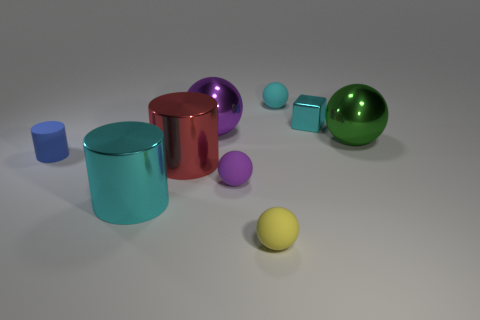Subtract all green balls. How many balls are left? 4 Subtract all green balls. How many balls are left? 4 Subtract all gray cylinders. How many brown blocks are left? 0 Subtract 0 red balls. How many objects are left? 9 Subtract all blocks. How many objects are left? 8 Subtract 2 spheres. How many spheres are left? 3 Subtract all red cylinders. Subtract all green cubes. How many cylinders are left? 2 Subtract all tiny blue cylinders. Subtract all small yellow rubber things. How many objects are left? 7 Add 7 small blue cylinders. How many small blue cylinders are left? 8 Add 6 tiny matte things. How many tiny matte things exist? 10 